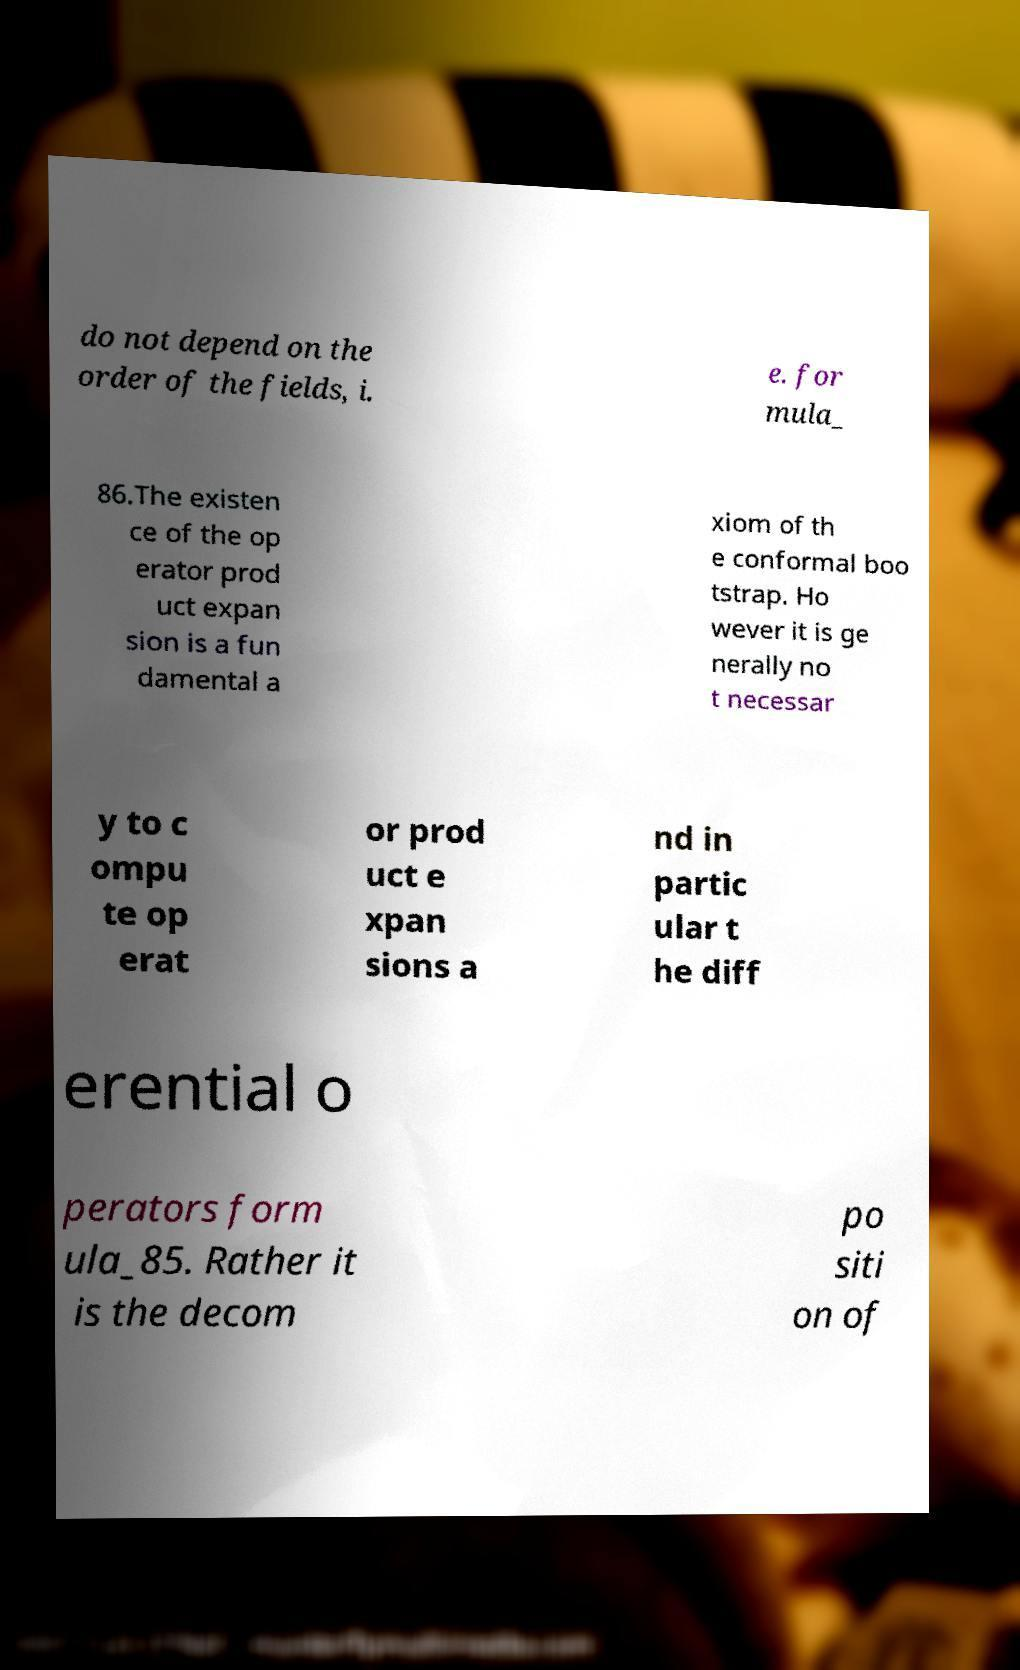For documentation purposes, I need the text within this image transcribed. Could you provide that? do not depend on the order of the fields, i. e. for mula_ 86.The existen ce of the op erator prod uct expan sion is a fun damental a xiom of th e conformal boo tstrap. Ho wever it is ge nerally no t necessar y to c ompu te op erat or prod uct e xpan sions a nd in partic ular t he diff erential o perators form ula_85. Rather it is the decom po siti on of 